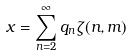Convert formula to latex. <formula><loc_0><loc_0><loc_500><loc_500>x = \sum _ { n = 2 } ^ { \infty } q _ { n } \zeta ( n , m )</formula> 